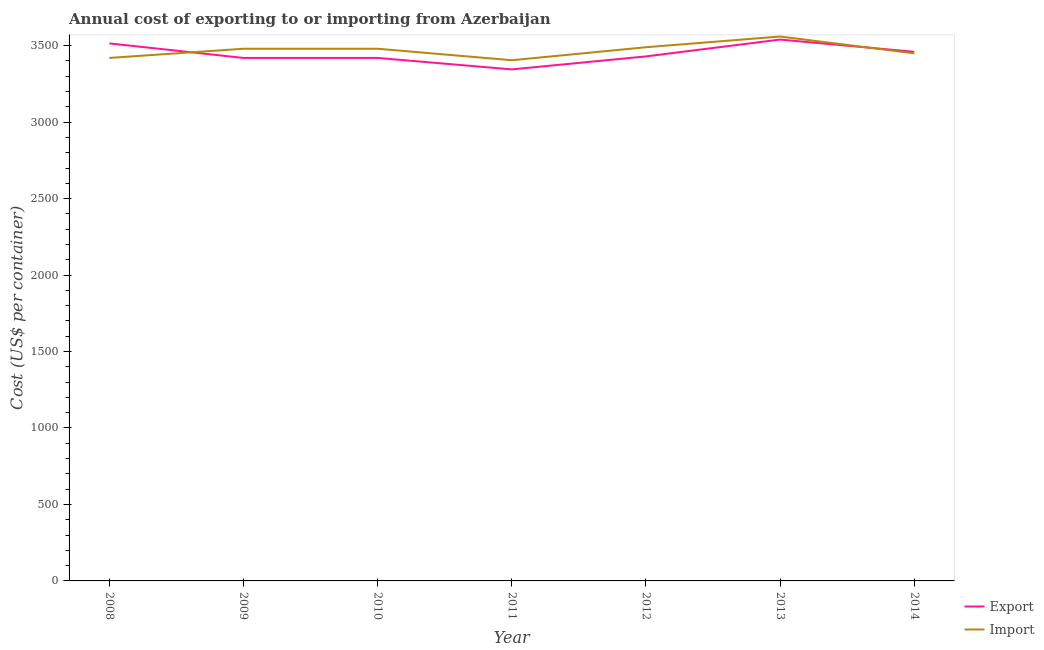Does the line corresponding to export cost intersect with the line corresponding to import cost?
Keep it short and to the point. Yes. Is the number of lines equal to the number of legend labels?
Your answer should be very brief. Yes. What is the export cost in 2010?
Provide a short and direct response. 3420. Across all years, what is the maximum export cost?
Offer a very short reply. 3540. Across all years, what is the minimum export cost?
Ensure brevity in your answer.  3345. What is the total import cost in the graph?
Your response must be concise. 2.43e+04. What is the difference between the export cost in 2012 and that in 2014?
Your answer should be very brief. -30. What is the difference between the export cost in 2013 and the import cost in 2009?
Give a very brief answer. 60. What is the average export cost per year?
Offer a terse response. 3447.14. In the year 2010, what is the difference between the import cost and export cost?
Your answer should be compact. 60. What is the ratio of the export cost in 2008 to that in 2009?
Your answer should be very brief. 1.03. Is the difference between the import cost in 2008 and 2013 greater than the difference between the export cost in 2008 and 2013?
Offer a very short reply. No. What is the difference between the highest and the lowest import cost?
Your response must be concise. 155. In how many years, is the import cost greater than the average import cost taken over all years?
Provide a short and direct response. 4. Does the export cost monotonically increase over the years?
Offer a very short reply. No. Is the import cost strictly greater than the export cost over the years?
Ensure brevity in your answer.  No. How many lines are there?
Keep it short and to the point. 2. How many years are there in the graph?
Offer a terse response. 7. What is the difference between two consecutive major ticks on the Y-axis?
Your answer should be very brief. 500. Does the graph contain grids?
Offer a terse response. No. How many legend labels are there?
Ensure brevity in your answer.  2. What is the title of the graph?
Your answer should be compact. Annual cost of exporting to or importing from Azerbaijan. Does "Net savings(excluding particulate emission damage)" appear as one of the legend labels in the graph?
Your response must be concise. No. What is the label or title of the X-axis?
Provide a short and direct response. Year. What is the label or title of the Y-axis?
Provide a succinct answer. Cost (US$ per container). What is the Cost (US$ per container) in Export in 2008?
Your answer should be very brief. 3515. What is the Cost (US$ per container) of Import in 2008?
Offer a terse response. 3420. What is the Cost (US$ per container) in Export in 2009?
Your response must be concise. 3420. What is the Cost (US$ per container) in Import in 2009?
Your answer should be compact. 3480. What is the Cost (US$ per container) of Export in 2010?
Your answer should be very brief. 3420. What is the Cost (US$ per container) in Import in 2010?
Your answer should be compact. 3480. What is the Cost (US$ per container) of Export in 2011?
Your answer should be compact. 3345. What is the Cost (US$ per container) of Import in 2011?
Your answer should be very brief. 3405. What is the Cost (US$ per container) of Export in 2012?
Provide a short and direct response. 3430. What is the Cost (US$ per container) in Import in 2012?
Your answer should be compact. 3490. What is the Cost (US$ per container) in Export in 2013?
Offer a terse response. 3540. What is the Cost (US$ per container) of Import in 2013?
Your answer should be very brief. 3560. What is the Cost (US$ per container) in Export in 2014?
Offer a very short reply. 3460. What is the Cost (US$ per container) in Import in 2014?
Offer a terse response. 3450. Across all years, what is the maximum Cost (US$ per container) in Export?
Your answer should be compact. 3540. Across all years, what is the maximum Cost (US$ per container) of Import?
Your answer should be compact. 3560. Across all years, what is the minimum Cost (US$ per container) in Export?
Provide a succinct answer. 3345. Across all years, what is the minimum Cost (US$ per container) of Import?
Provide a short and direct response. 3405. What is the total Cost (US$ per container) of Export in the graph?
Offer a very short reply. 2.41e+04. What is the total Cost (US$ per container) of Import in the graph?
Your answer should be very brief. 2.43e+04. What is the difference between the Cost (US$ per container) in Import in 2008 and that in 2009?
Provide a succinct answer. -60. What is the difference between the Cost (US$ per container) of Export in 2008 and that in 2010?
Offer a terse response. 95. What is the difference between the Cost (US$ per container) of Import in 2008 and that in 2010?
Your response must be concise. -60. What is the difference between the Cost (US$ per container) in Export in 2008 and that in 2011?
Keep it short and to the point. 170. What is the difference between the Cost (US$ per container) of Import in 2008 and that in 2011?
Your response must be concise. 15. What is the difference between the Cost (US$ per container) of Import in 2008 and that in 2012?
Provide a short and direct response. -70. What is the difference between the Cost (US$ per container) in Export in 2008 and that in 2013?
Keep it short and to the point. -25. What is the difference between the Cost (US$ per container) in Import in 2008 and that in 2013?
Offer a terse response. -140. What is the difference between the Cost (US$ per container) of Export in 2009 and that in 2010?
Your answer should be very brief. 0. What is the difference between the Cost (US$ per container) in Import in 2009 and that in 2010?
Your answer should be very brief. 0. What is the difference between the Cost (US$ per container) of Export in 2009 and that in 2011?
Your response must be concise. 75. What is the difference between the Cost (US$ per container) in Export in 2009 and that in 2012?
Give a very brief answer. -10. What is the difference between the Cost (US$ per container) in Export in 2009 and that in 2013?
Give a very brief answer. -120. What is the difference between the Cost (US$ per container) of Import in 2009 and that in 2013?
Offer a terse response. -80. What is the difference between the Cost (US$ per container) in Export in 2009 and that in 2014?
Offer a terse response. -40. What is the difference between the Cost (US$ per container) of Export in 2010 and that in 2011?
Your response must be concise. 75. What is the difference between the Cost (US$ per container) of Import in 2010 and that in 2011?
Provide a short and direct response. 75. What is the difference between the Cost (US$ per container) in Import in 2010 and that in 2012?
Provide a succinct answer. -10. What is the difference between the Cost (US$ per container) of Export in 2010 and that in 2013?
Ensure brevity in your answer.  -120. What is the difference between the Cost (US$ per container) of Import in 2010 and that in 2013?
Provide a succinct answer. -80. What is the difference between the Cost (US$ per container) in Export in 2011 and that in 2012?
Provide a short and direct response. -85. What is the difference between the Cost (US$ per container) in Import in 2011 and that in 2012?
Provide a succinct answer. -85. What is the difference between the Cost (US$ per container) of Export in 2011 and that in 2013?
Offer a terse response. -195. What is the difference between the Cost (US$ per container) of Import in 2011 and that in 2013?
Make the answer very short. -155. What is the difference between the Cost (US$ per container) of Export in 2011 and that in 2014?
Ensure brevity in your answer.  -115. What is the difference between the Cost (US$ per container) in Import in 2011 and that in 2014?
Your answer should be very brief. -45. What is the difference between the Cost (US$ per container) of Export in 2012 and that in 2013?
Your answer should be compact. -110. What is the difference between the Cost (US$ per container) of Import in 2012 and that in 2013?
Your answer should be very brief. -70. What is the difference between the Cost (US$ per container) in Export in 2012 and that in 2014?
Provide a short and direct response. -30. What is the difference between the Cost (US$ per container) in Import in 2013 and that in 2014?
Keep it short and to the point. 110. What is the difference between the Cost (US$ per container) of Export in 2008 and the Cost (US$ per container) of Import in 2010?
Keep it short and to the point. 35. What is the difference between the Cost (US$ per container) in Export in 2008 and the Cost (US$ per container) in Import in 2011?
Make the answer very short. 110. What is the difference between the Cost (US$ per container) in Export in 2008 and the Cost (US$ per container) in Import in 2012?
Keep it short and to the point. 25. What is the difference between the Cost (US$ per container) of Export in 2008 and the Cost (US$ per container) of Import in 2013?
Ensure brevity in your answer.  -45. What is the difference between the Cost (US$ per container) of Export in 2008 and the Cost (US$ per container) of Import in 2014?
Ensure brevity in your answer.  65. What is the difference between the Cost (US$ per container) of Export in 2009 and the Cost (US$ per container) of Import in 2010?
Your answer should be very brief. -60. What is the difference between the Cost (US$ per container) in Export in 2009 and the Cost (US$ per container) in Import in 2011?
Keep it short and to the point. 15. What is the difference between the Cost (US$ per container) of Export in 2009 and the Cost (US$ per container) of Import in 2012?
Provide a succinct answer. -70. What is the difference between the Cost (US$ per container) in Export in 2009 and the Cost (US$ per container) in Import in 2013?
Offer a terse response. -140. What is the difference between the Cost (US$ per container) in Export in 2010 and the Cost (US$ per container) in Import in 2012?
Offer a very short reply. -70. What is the difference between the Cost (US$ per container) of Export in 2010 and the Cost (US$ per container) of Import in 2013?
Your answer should be very brief. -140. What is the difference between the Cost (US$ per container) of Export in 2011 and the Cost (US$ per container) of Import in 2012?
Offer a very short reply. -145. What is the difference between the Cost (US$ per container) in Export in 2011 and the Cost (US$ per container) in Import in 2013?
Your answer should be compact. -215. What is the difference between the Cost (US$ per container) in Export in 2011 and the Cost (US$ per container) in Import in 2014?
Your response must be concise. -105. What is the difference between the Cost (US$ per container) of Export in 2012 and the Cost (US$ per container) of Import in 2013?
Give a very brief answer. -130. What is the difference between the Cost (US$ per container) of Export in 2013 and the Cost (US$ per container) of Import in 2014?
Offer a very short reply. 90. What is the average Cost (US$ per container) of Export per year?
Your answer should be very brief. 3447.14. What is the average Cost (US$ per container) of Import per year?
Your response must be concise. 3469.29. In the year 2009, what is the difference between the Cost (US$ per container) in Export and Cost (US$ per container) in Import?
Offer a very short reply. -60. In the year 2010, what is the difference between the Cost (US$ per container) in Export and Cost (US$ per container) in Import?
Make the answer very short. -60. In the year 2011, what is the difference between the Cost (US$ per container) of Export and Cost (US$ per container) of Import?
Provide a succinct answer. -60. In the year 2012, what is the difference between the Cost (US$ per container) of Export and Cost (US$ per container) of Import?
Your response must be concise. -60. In the year 2013, what is the difference between the Cost (US$ per container) of Export and Cost (US$ per container) of Import?
Make the answer very short. -20. What is the ratio of the Cost (US$ per container) of Export in 2008 to that in 2009?
Provide a short and direct response. 1.03. What is the ratio of the Cost (US$ per container) of Import in 2008 to that in 2009?
Your answer should be compact. 0.98. What is the ratio of the Cost (US$ per container) of Export in 2008 to that in 2010?
Your response must be concise. 1.03. What is the ratio of the Cost (US$ per container) of Import in 2008 to that in 2010?
Provide a short and direct response. 0.98. What is the ratio of the Cost (US$ per container) of Export in 2008 to that in 2011?
Your answer should be compact. 1.05. What is the ratio of the Cost (US$ per container) of Import in 2008 to that in 2011?
Offer a very short reply. 1. What is the ratio of the Cost (US$ per container) of Export in 2008 to that in 2012?
Offer a terse response. 1.02. What is the ratio of the Cost (US$ per container) in Import in 2008 to that in 2012?
Your answer should be compact. 0.98. What is the ratio of the Cost (US$ per container) in Import in 2008 to that in 2013?
Your answer should be very brief. 0.96. What is the ratio of the Cost (US$ per container) of Export in 2008 to that in 2014?
Your answer should be compact. 1.02. What is the ratio of the Cost (US$ per container) of Import in 2008 to that in 2014?
Your answer should be compact. 0.99. What is the ratio of the Cost (US$ per container) in Export in 2009 to that in 2010?
Your answer should be very brief. 1. What is the ratio of the Cost (US$ per container) in Export in 2009 to that in 2011?
Your response must be concise. 1.02. What is the ratio of the Cost (US$ per container) of Export in 2009 to that in 2012?
Give a very brief answer. 1. What is the ratio of the Cost (US$ per container) of Export in 2009 to that in 2013?
Give a very brief answer. 0.97. What is the ratio of the Cost (US$ per container) of Import in 2009 to that in 2013?
Offer a terse response. 0.98. What is the ratio of the Cost (US$ per container) of Export in 2009 to that in 2014?
Your answer should be compact. 0.99. What is the ratio of the Cost (US$ per container) in Import in 2009 to that in 2014?
Offer a terse response. 1.01. What is the ratio of the Cost (US$ per container) of Export in 2010 to that in 2011?
Offer a very short reply. 1.02. What is the ratio of the Cost (US$ per container) in Export in 2010 to that in 2012?
Ensure brevity in your answer.  1. What is the ratio of the Cost (US$ per container) of Export in 2010 to that in 2013?
Provide a succinct answer. 0.97. What is the ratio of the Cost (US$ per container) in Import in 2010 to that in 2013?
Make the answer very short. 0.98. What is the ratio of the Cost (US$ per container) of Export in 2010 to that in 2014?
Ensure brevity in your answer.  0.99. What is the ratio of the Cost (US$ per container) in Import in 2010 to that in 2014?
Give a very brief answer. 1.01. What is the ratio of the Cost (US$ per container) of Export in 2011 to that in 2012?
Offer a terse response. 0.98. What is the ratio of the Cost (US$ per container) in Import in 2011 to that in 2012?
Make the answer very short. 0.98. What is the ratio of the Cost (US$ per container) of Export in 2011 to that in 2013?
Keep it short and to the point. 0.94. What is the ratio of the Cost (US$ per container) in Import in 2011 to that in 2013?
Provide a succinct answer. 0.96. What is the ratio of the Cost (US$ per container) of Export in 2011 to that in 2014?
Provide a short and direct response. 0.97. What is the ratio of the Cost (US$ per container) in Import in 2011 to that in 2014?
Offer a terse response. 0.99. What is the ratio of the Cost (US$ per container) of Export in 2012 to that in 2013?
Offer a terse response. 0.97. What is the ratio of the Cost (US$ per container) in Import in 2012 to that in 2013?
Offer a very short reply. 0.98. What is the ratio of the Cost (US$ per container) in Export in 2012 to that in 2014?
Ensure brevity in your answer.  0.99. What is the ratio of the Cost (US$ per container) in Import in 2012 to that in 2014?
Keep it short and to the point. 1.01. What is the ratio of the Cost (US$ per container) in Export in 2013 to that in 2014?
Give a very brief answer. 1.02. What is the ratio of the Cost (US$ per container) in Import in 2013 to that in 2014?
Provide a succinct answer. 1.03. What is the difference between the highest and the second highest Cost (US$ per container) of Import?
Your answer should be compact. 70. What is the difference between the highest and the lowest Cost (US$ per container) of Export?
Give a very brief answer. 195. What is the difference between the highest and the lowest Cost (US$ per container) of Import?
Offer a terse response. 155. 